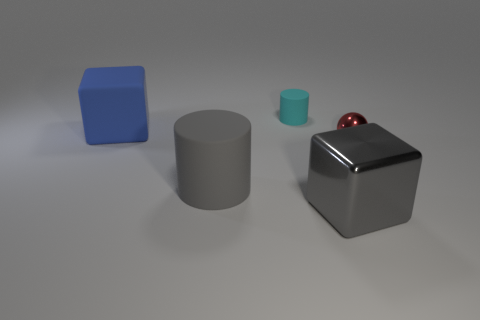How many objects are behind the big rubber thing that is in front of the big blue cube?
Provide a succinct answer. 3. There is a large gray object that is on the right side of the gray object that is on the left side of the big cube on the right side of the small cyan thing; what shape is it?
Your answer should be very brief. Cube. What is the size of the metal block that is the same color as the big matte cylinder?
Give a very brief answer. Large. How many things are either small metallic balls or large gray cubes?
Offer a terse response. 2. What is the color of the rubber cylinder that is the same size as the red metallic object?
Your answer should be very brief. Cyan. There is a cyan rubber object; does it have the same shape as the shiny thing that is left of the tiny sphere?
Give a very brief answer. No. How many objects are either rubber things that are on the left side of the cyan rubber thing or cubes to the left of the gray shiny block?
Your answer should be very brief. 2. There is a metal object that is the same color as the large matte cylinder; what shape is it?
Keep it short and to the point. Cube. There is a small thing right of the cyan rubber object; what shape is it?
Offer a terse response. Sphere. There is a gray object that is to the left of the small cyan cylinder; is it the same shape as the tiny red object?
Keep it short and to the point. No. 